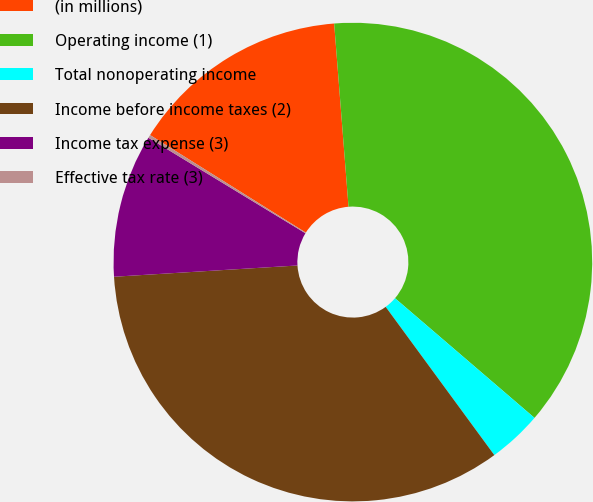Convert chart. <chart><loc_0><loc_0><loc_500><loc_500><pie_chart><fcel>(in millions)<fcel>Operating income (1)<fcel>Total nonoperating income<fcel>Income before income taxes (2)<fcel>Income tax expense (3)<fcel>Effective tax rate (3)<nl><fcel>14.85%<fcel>37.53%<fcel>3.65%<fcel>34.09%<fcel>9.67%<fcel>0.21%<nl></chart> 